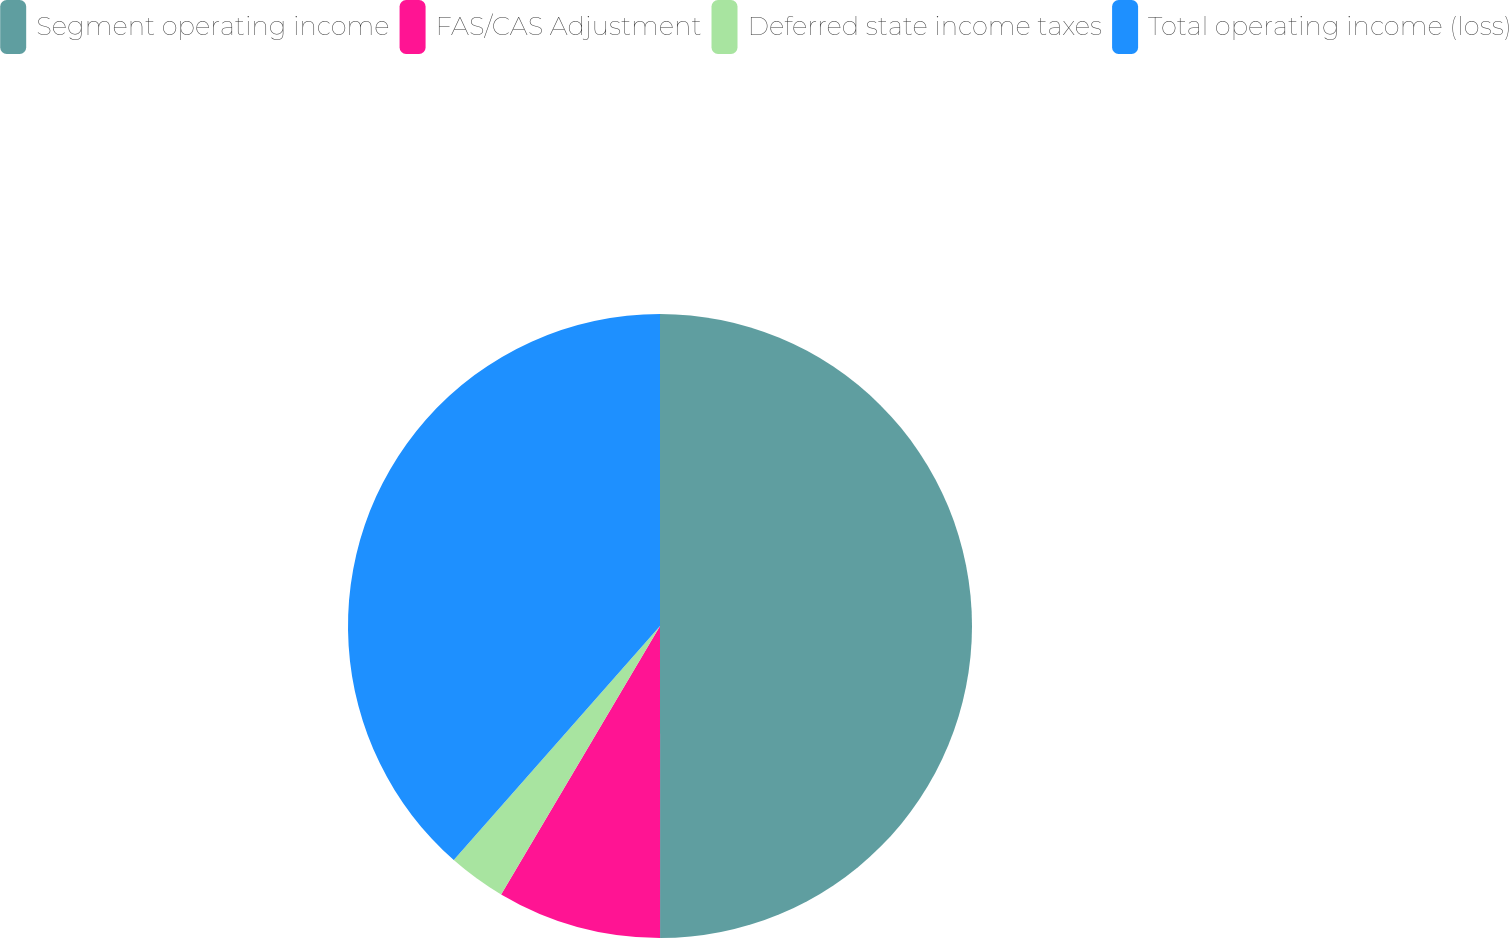Convert chart. <chart><loc_0><loc_0><loc_500><loc_500><pie_chart><fcel>Segment operating income<fcel>FAS/CAS Adjustment<fcel>Deferred state income taxes<fcel>Total operating income (loss)<nl><fcel>50.0%<fcel>8.51%<fcel>2.99%<fcel>38.51%<nl></chart> 